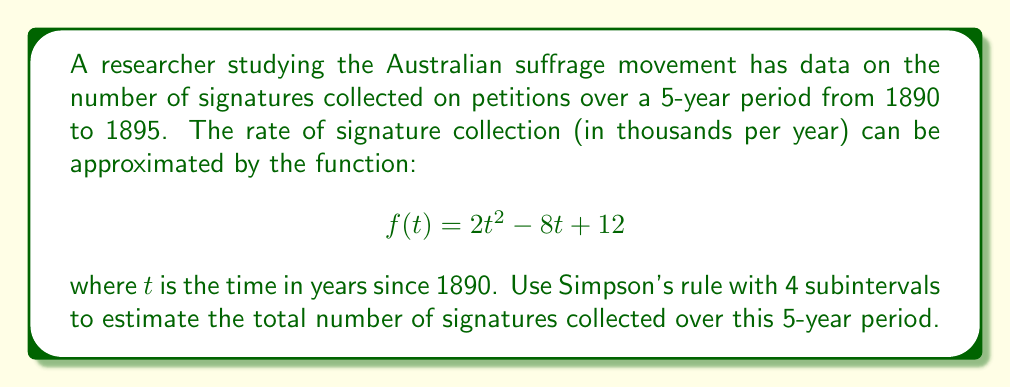Teach me how to tackle this problem. To solve this problem, we'll use Simpson's rule for numerical integration. Simpson's rule is given by:

$$\int_a^b f(x)dx \approx \frac{h}{3}[f(x_0) + 4f(x_1) + 2f(x_2) + 4f(x_3) + f(x_4)]$$

where $h = \frac{b-a}{n}$ and $n$ is the number of subintervals (in this case, 4).

Steps:
1) Identify the limits of integration: $a = 0$, $b = 5$
2) Calculate $h$: $h = \frac{5-0}{4} = 1.25$
3) Calculate the values of $f(t)$ at $t = 0, 1.25, 2.5, 3.75, 5$:

   $f(0) = 2(0)^2 - 8(0) + 12 = 12$
   $f(1.25) = 2(1.25)^2 - 8(1.25) + 12 = 7.125$
   $f(2.5) = 2(2.5)^2 - 8(2.5) + 12 = 7.5$
   $f(3.75) = 2(3.75)^2 - 8(3.75) + 12 = 13.125$
   $f(5) = 2(5)^2 - 8(5) + 12 = 22$

4) Apply Simpson's rule:

   $$\int_0^5 f(t)dt \approx \frac{1.25}{3}[12 + 4(7.125) + 2(7.5) + 4(13.125) + 22]$$
   $$= \frac{1.25}{3}[12 + 28.5 + 15 + 52.5 + 22]$$
   $$= \frac{1.25}{3}(130) = 54.1667$$

5) Since $f(t)$ is in thousands of signatures per year, multiply the result by 1000 to get the total number of signatures.

   $54.1667 * 1000 = 54,166.7$

Therefore, the estimated total number of signatures collected over the 5-year period is approximately 54,167.
Answer: 54,167 signatures 